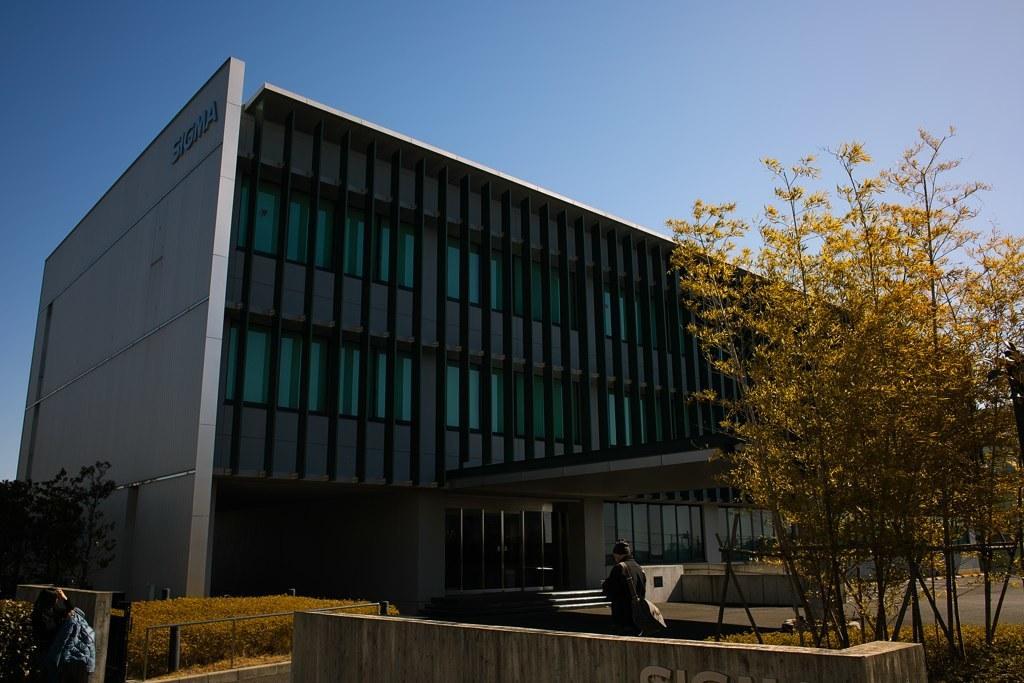In one or two sentences, can you explain what this image depicts? In the center of the image there is a building. At the bottom we can see people, trees and shed. In the background there is sky. 